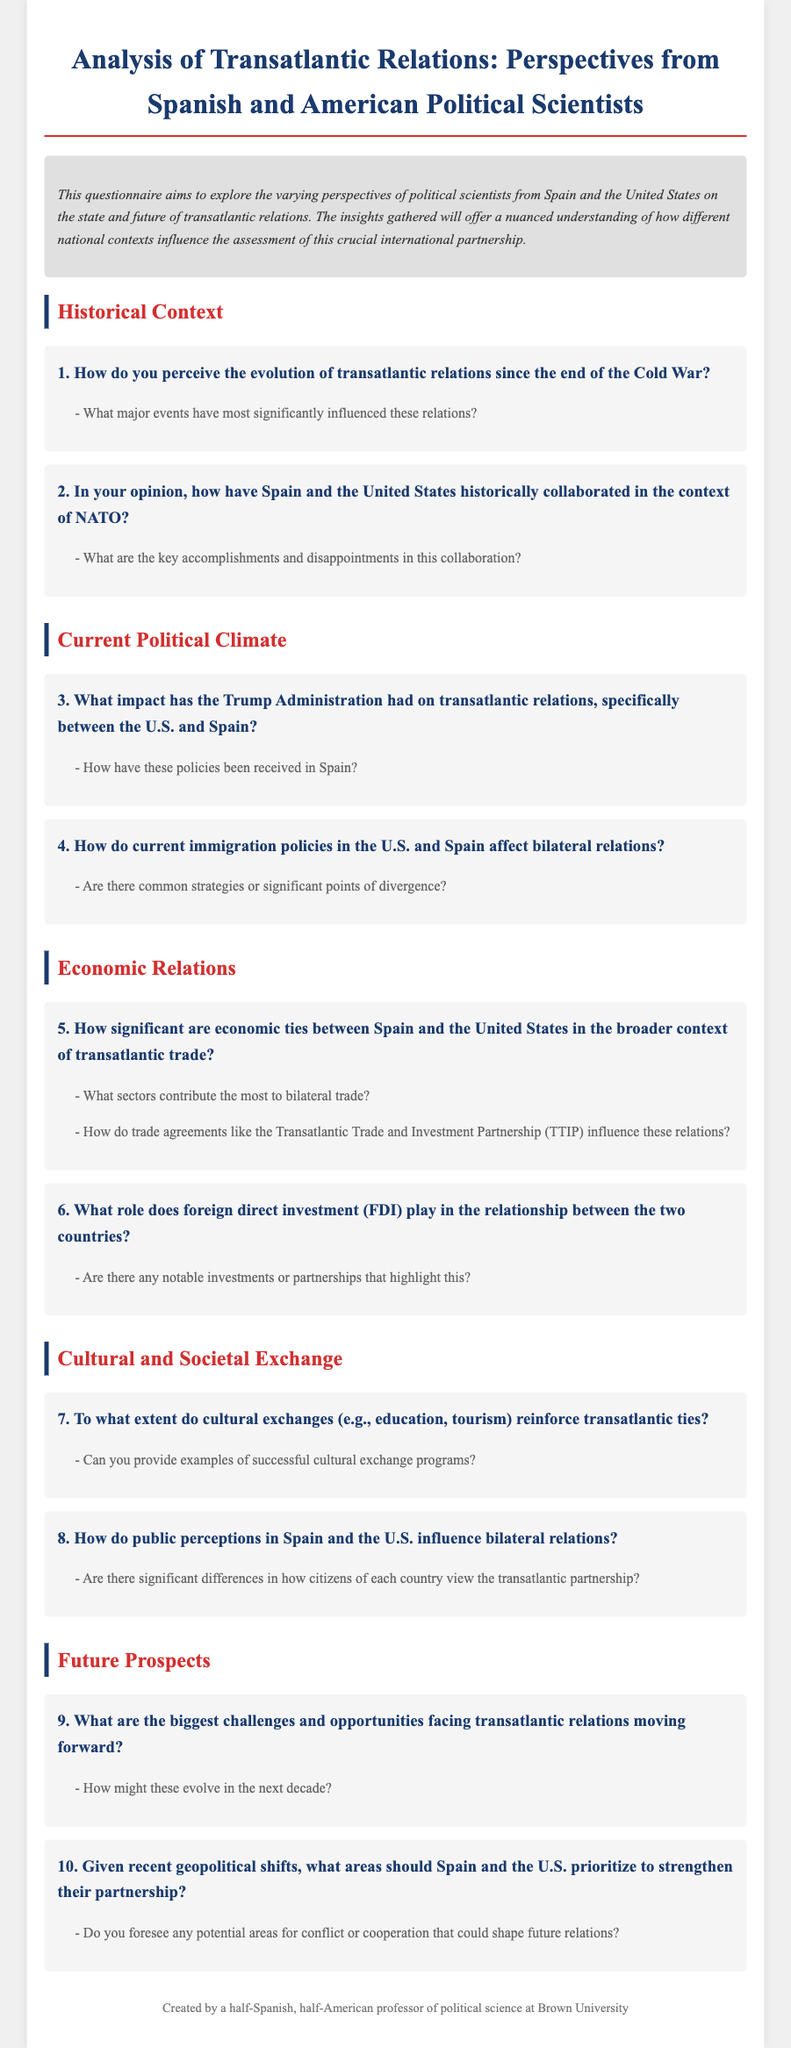What is the title of the questionnaire? The title provides a clear identification of the content and purpose of the document.
Answer: Analysis of Transatlantic Relations: Perspectives from Spanish and American Political Scientists Who created the questionnaire? The footer specifies the author of the document.
Answer: a half-Spanish, half-American professor of political science at Brown University What is one of the sections in the document? The sections categorize the different themes explored within the questionnaire.
Answer: Historical Context How many major sections are in the document? By counting the main headings, we identify the organizational structure of the questionnaire.
Answer: Five What is one example of a sub-question in the economic relations section? This sub-question gives deeper insight into the specific topics addressed within the main question of the section.
Answer: What sectors contribute the most to bilateral trade? What topic does question 9 address? This provides information on the focus of one of the questions within the "Future Prospects" section.
Answer: Challenges and opportunities How does the document describe cultural exchanges? This question looks for a specific description or evaluation regarding cultural exchanges mentioned in the document.
Answer: Reinforce transatlantic ties 